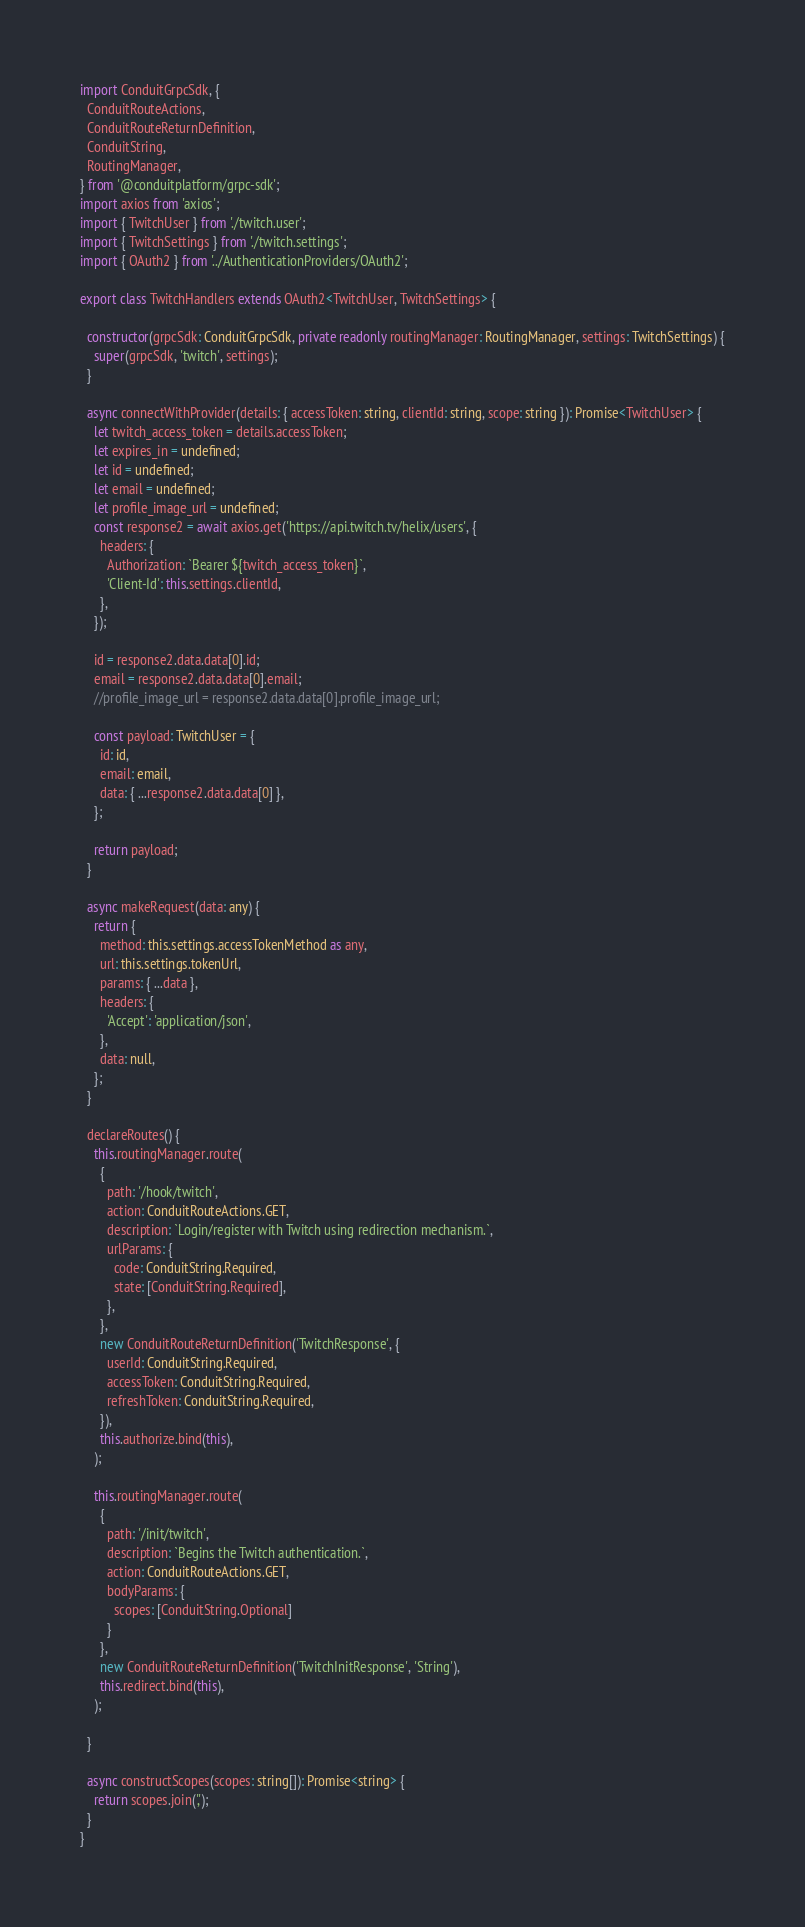<code> <loc_0><loc_0><loc_500><loc_500><_TypeScript_>import ConduitGrpcSdk, {
  ConduitRouteActions,
  ConduitRouteReturnDefinition,
  ConduitString,
  RoutingManager,
} from '@conduitplatform/grpc-sdk';
import axios from 'axios';
import { TwitchUser } from './twitch.user';
import { TwitchSettings } from './twitch.settings';
import { OAuth2 } from '../AuthenticationProviders/OAuth2';

export class TwitchHandlers extends OAuth2<TwitchUser, TwitchSettings> {

  constructor(grpcSdk: ConduitGrpcSdk, private readonly routingManager: RoutingManager, settings: TwitchSettings) {
    super(grpcSdk, 'twitch', settings);
  }

  async connectWithProvider(details: { accessToken: string, clientId: string, scope: string }): Promise<TwitchUser> {
    let twitch_access_token = details.accessToken;
    let expires_in = undefined;
    let id = undefined;
    let email = undefined;
    let profile_image_url = undefined;
    const response2 = await axios.get('https://api.twitch.tv/helix/users', {
      headers: {
        Authorization: `Bearer ${twitch_access_token}`,
        'Client-Id': this.settings.clientId,
      },
    });

    id = response2.data.data[0].id;
    email = response2.data.data[0].email;
    //profile_image_url = response2.data.data[0].profile_image_url;

    const payload: TwitchUser = {
      id: id,
      email: email,
      data: { ...response2.data.data[0] },
    };

    return payload;
  }

  async makeRequest(data: any) {
    return {
      method: this.settings.accessTokenMethod as any,
      url: this.settings.tokenUrl,
      params: { ...data },
      headers: {
        'Accept': 'application/json',
      },
      data: null,
    };
  }

  declareRoutes() {
    this.routingManager.route(
      {
        path: '/hook/twitch',
        action: ConduitRouteActions.GET,
        description: `Login/register with Twitch using redirection mechanism.`,
        urlParams: {
          code: ConduitString.Required,
          state: [ConduitString.Required],
        },
      },
      new ConduitRouteReturnDefinition('TwitchResponse', {
        userId: ConduitString.Required,
        accessToken: ConduitString.Required,
        refreshToken: ConduitString.Required,
      }),
      this.authorize.bind(this),
    );

    this.routingManager.route(
      {
        path: '/init/twitch',
        description: `Begins the Twitch authentication.`,
        action: ConduitRouteActions.GET,
        bodyParams: {
          scopes: [ConduitString.Optional]
        }
      },
      new ConduitRouteReturnDefinition('TwitchInitResponse', 'String'),
      this.redirect.bind(this),
    );

  }

  async constructScopes(scopes: string[]): Promise<string> {
    return scopes.join(',');
  }
}
</code> 